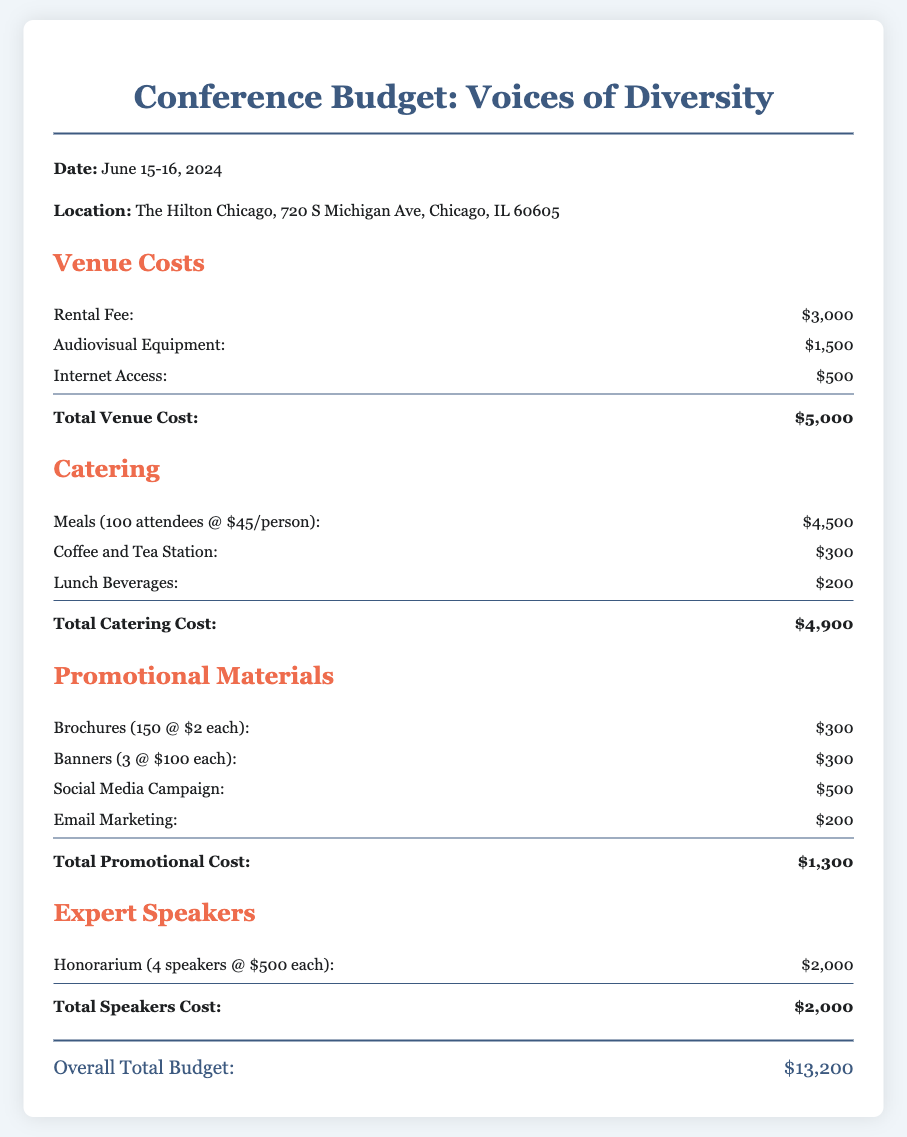What is the date of the conference? The date of the conference is stated in the document as June 15-16, 2024.
Answer: June 15-16, 2024 What is the total venue cost? The total venue cost is provided in the budget section under Venue Costs, which sums to $5,000.
Answer: $5,000 How much is allocated for meals per person? The document specifies the cost for meals as $45 per person for 100 attendees.
Answer: $45 What is the total cost for speakers? The total cost listed for expert speakers is $2,000, calculated from four speakers at $500 each.
Answer: $2,000 What is the overall total budget for the conference? The overall total budget is the sum of all costs detailed in the document, which amounts to $13,200.
Answer: $13,200 How many brochures are planned for promotion? The budget indicates that 150 brochures are planned at a cost of $2 each.
Answer: 150 What is the cost of internet access? The document mentions the cost for internet access as part of the venue costs, which is $500.
Answer: $500 What type of materials are included in promotional costs? The promotional materials include brochures, banners, social media campaign, and email marketing as outlined in the document.
Answer: Brochures, banners, social media campaign, email marketing What is the cost for lunch beverages? The lunch beverages cost specified in the catering section of the budget is $200.
Answer: $200 